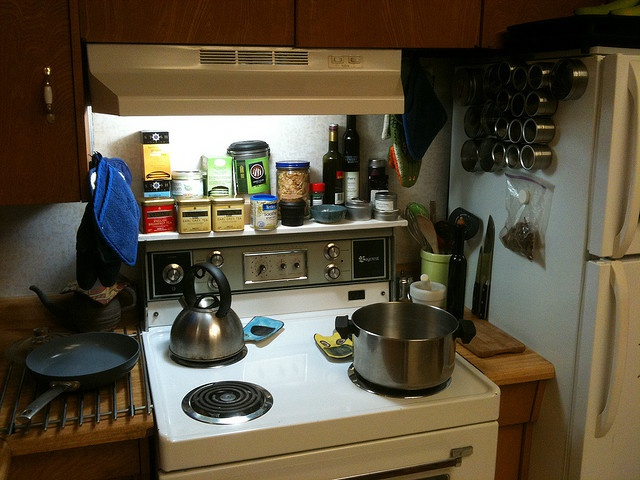Describe the objects in this image and their specific colors. I can see oven in black, olive, lightgray, and gray tones, refrigerator in black, gray, and olive tones, bottle in black, maroon, and gray tones, bottle in black, darkgreen, maroon, and gray tones, and bottle in black, darkgray, gray, and darkgreen tones in this image. 